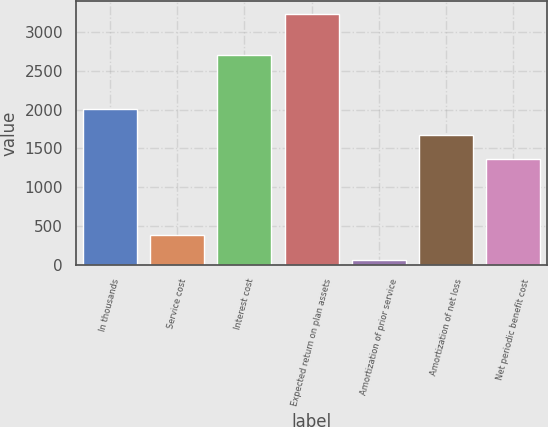Convert chart to OTSL. <chart><loc_0><loc_0><loc_500><loc_500><bar_chart><fcel>In thousands<fcel>Service cost<fcel>Interest cost<fcel>Expected return on plan assets<fcel>Amortization of prior service<fcel>Amortization of net loss<fcel>Net periodic benefit cost<nl><fcel>2007<fcel>376.8<fcel>2710<fcel>3237<fcel>59<fcel>1676.8<fcel>1359<nl></chart> 